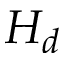<formula> <loc_0><loc_0><loc_500><loc_500>H _ { d }</formula> 